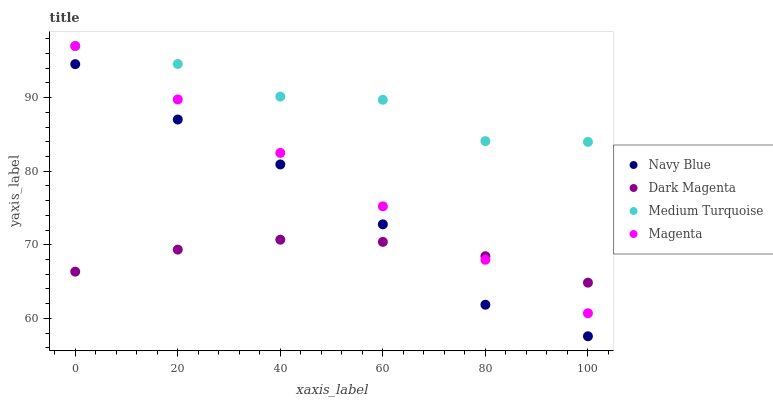Does Dark Magenta have the minimum area under the curve?
Answer yes or no. Yes. Does Medium Turquoise have the maximum area under the curve?
Answer yes or no. Yes. Does Magenta have the minimum area under the curve?
Answer yes or no. No. Does Magenta have the maximum area under the curve?
Answer yes or no. No. Is Magenta the smoothest?
Answer yes or no. Yes. Is Medium Turquoise the roughest?
Answer yes or no. Yes. Is Dark Magenta the smoothest?
Answer yes or no. No. Is Dark Magenta the roughest?
Answer yes or no. No. Does Navy Blue have the lowest value?
Answer yes or no. Yes. Does Magenta have the lowest value?
Answer yes or no. No. Does Medium Turquoise have the highest value?
Answer yes or no. Yes. Does Dark Magenta have the highest value?
Answer yes or no. No. Is Navy Blue less than Medium Turquoise?
Answer yes or no. Yes. Is Medium Turquoise greater than Dark Magenta?
Answer yes or no. Yes. Does Navy Blue intersect Dark Magenta?
Answer yes or no. Yes. Is Navy Blue less than Dark Magenta?
Answer yes or no. No. Is Navy Blue greater than Dark Magenta?
Answer yes or no. No. Does Navy Blue intersect Medium Turquoise?
Answer yes or no. No. 